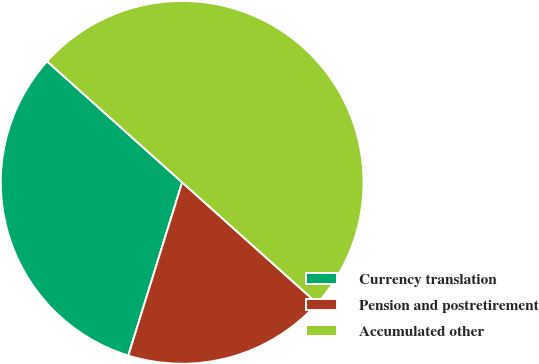<chart> <loc_0><loc_0><loc_500><loc_500><pie_chart><fcel>Currency translation<fcel>Pension and postretirement<fcel>Accumulated other<nl><fcel>31.83%<fcel>18.17%<fcel>50.0%<nl></chart> 